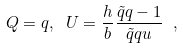Convert formula to latex. <formula><loc_0><loc_0><loc_500><loc_500>Q = q , \text { } U = \frac { h } { b } \frac { \tilde { q } q - 1 } { \tilde { q } q u } \text { } ,</formula> 